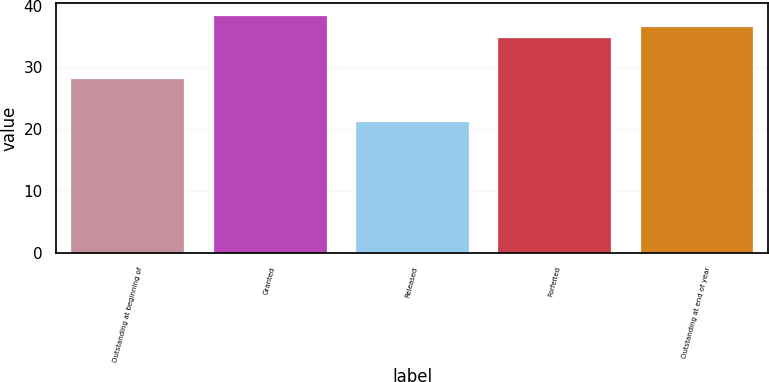Convert chart to OTSL. <chart><loc_0><loc_0><loc_500><loc_500><bar_chart><fcel>Outstanding at beginning of<fcel>Granted<fcel>Released<fcel>Forfeited<fcel>Outstanding at end of year<nl><fcel>28.2<fcel>38.45<fcel>21.39<fcel>34.9<fcel>36.61<nl></chart> 